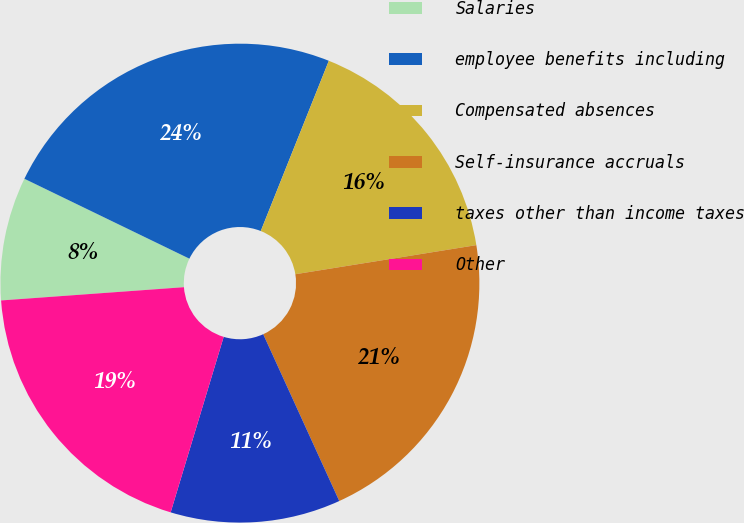Convert chart to OTSL. <chart><loc_0><loc_0><loc_500><loc_500><pie_chart><fcel>Salaries<fcel>employee benefits including<fcel>Compensated absences<fcel>Self-insurance accruals<fcel>taxes other than income taxes<fcel>Other<nl><fcel>8.33%<fcel>23.88%<fcel>16.41%<fcel>20.73%<fcel>11.48%<fcel>19.18%<nl></chart> 